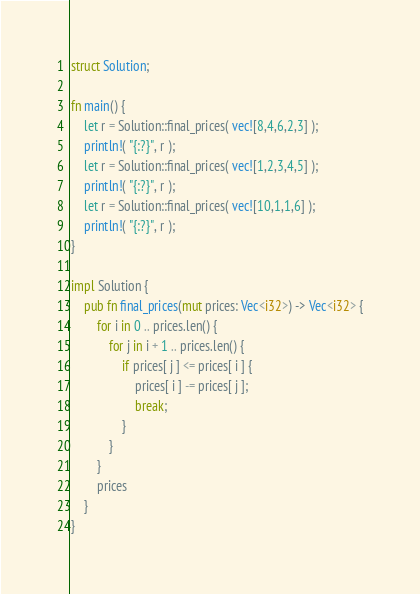<code> <loc_0><loc_0><loc_500><loc_500><_Rust_>struct Solution;

fn main() {
    let r = Solution::final_prices( vec![8,4,6,2,3] );
    println!( "{:?}", r );
    let r = Solution::final_prices( vec![1,2,3,4,5] );
    println!( "{:?}", r );
    let r = Solution::final_prices( vec![10,1,1,6] );
    println!( "{:?}", r );
}

impl Solution {
    pub fn final_prices(mut prices: Vec<i32>) -> Vec<i32> {
        for i in 0 .. prices.len() {
            for j in i + 1 .. prices.len() {
                if prices[ j ] <= prices[ i ] {
                    prices[ i ] -= prices[ j ];
                    break;
                }
            }
        }
        prices
    }
}
</code> 